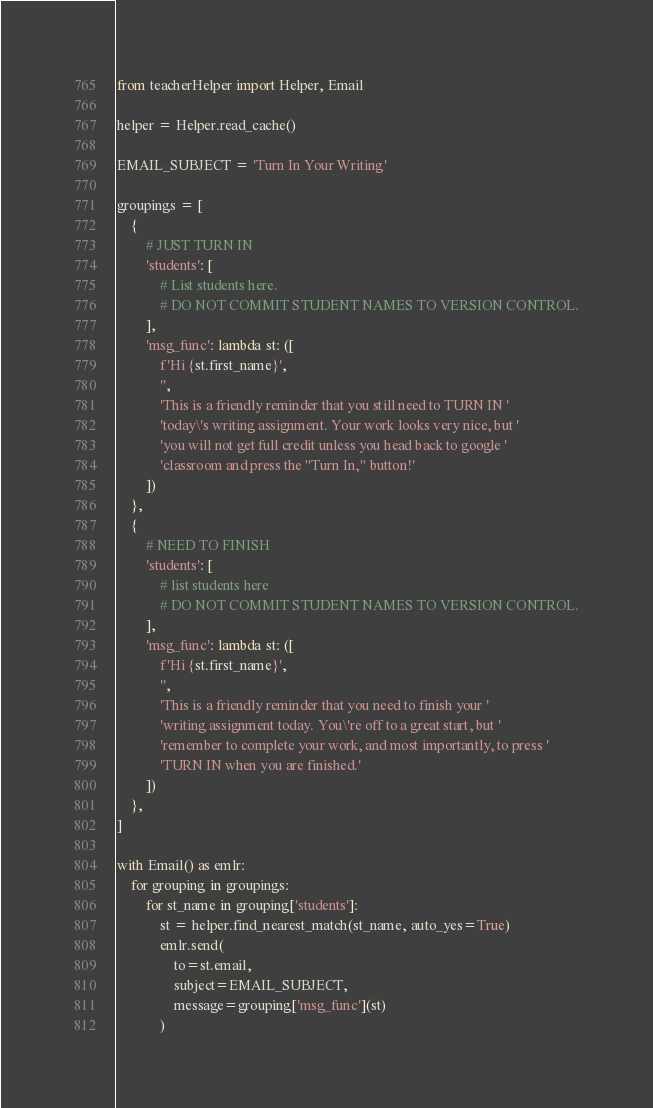<code> <loc_0><loc_0><loc_500><loc_500><_Python_>from teacherHelper import Helper, Email

helper = Helper.read_cache()

EMAIL_SUBJECT = 'Turn In Your Writing'

groupings = [
    {
        # JUST TURN IN
        'students': [
            # List students here.
            # DO NOT COMMIT STUDENT NAMES TO VERSION CONTROL.
        ],
        'msg_func': lambda st: ([
            f'Hi {st.first_name}',
            '',
            'This is a friendly reminder that you still need to TURN IN '
            'today\'s writing assignment. Your work looks very nice, but '
            'you will not get full credit unless you head back to google '
            'classroom and press the "Turn In," button!'
        ])
    },
    {
        # NEED TO FINISH
        'students': [
            # list students here
            # DO NOT COMMIT STUDENT NAMES TO VERSION CONTROL.
        ],
        'msg_func': lambda st: ([
            f'Hi {st.first_name}',
            '',
            'This is a friendly reminder that you need to finish your '
            'writing assignment today. You\'re off to a great start, but '
            'remember to complete your work, and most importantly, to press '
            'TURN IN when you are finished.'
        ])
    },
]

with Email() as emlr:
    for grouping in groupings:
        for st_name in grouping['students']:
            st = helper.find_nearest_match(st_name, auto_yes=True)
            emlr.send(
                to=st.email,
                subject=EMAIL_SUBJECT,
                message=grouping['msg_func'](st)
            )
</code> 